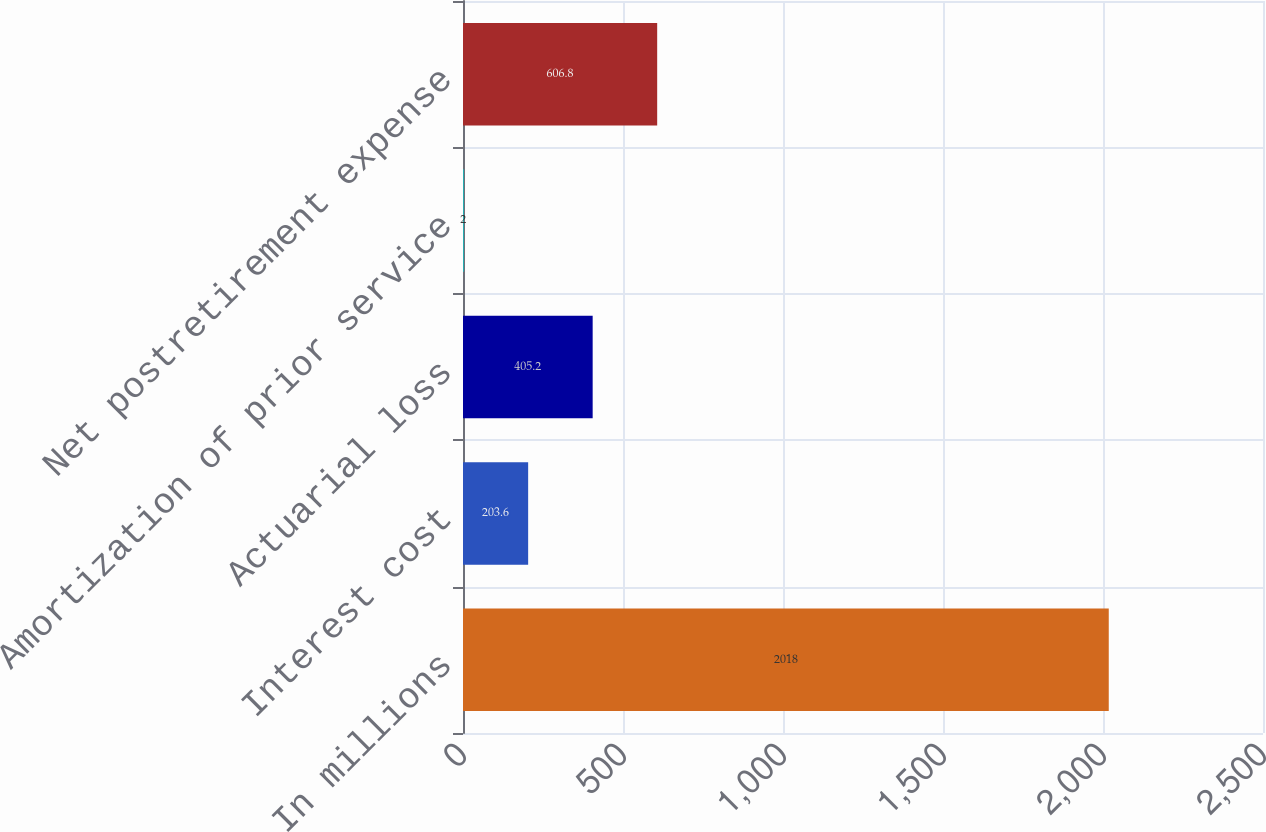Convert chart. <chart><loc_0><loc_0><loc_500><loc_500><bar_chart><fcel>In millions<fcel>Interest cost<fcel>Actuarial loss<fcel>Amortization of prior service<fcel>Net postretirement expense<nl><fcel>2018<fcel>203.6<fcel>405.2<fcel>2<fcel>606.8<nl></chart> 